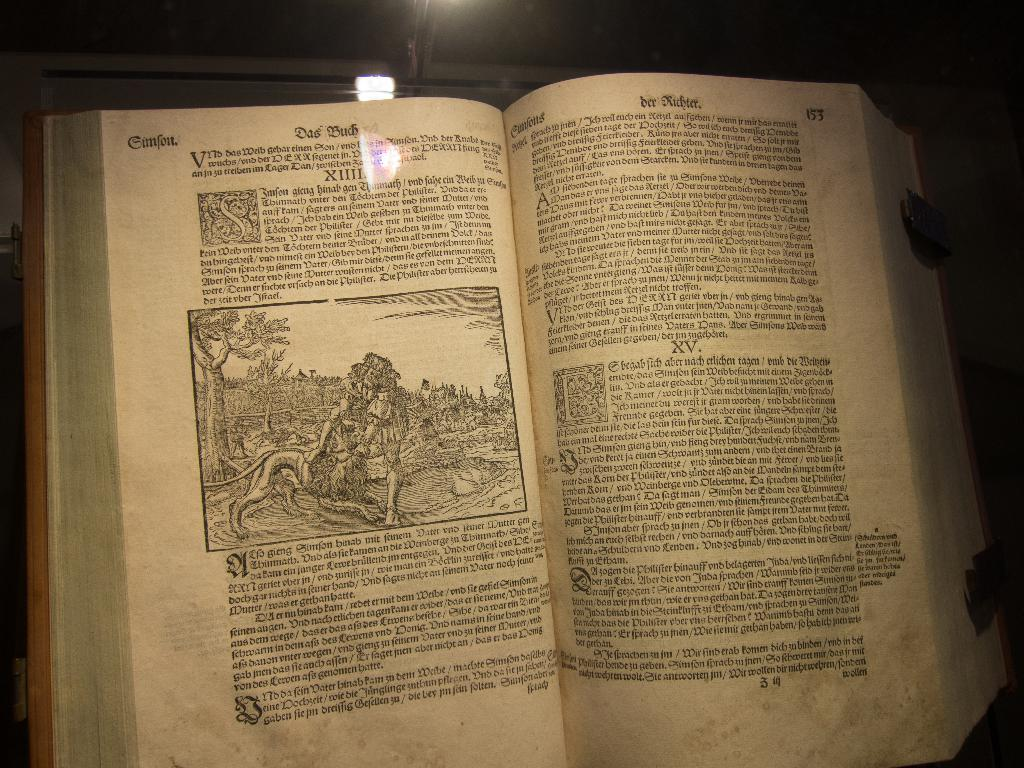What object can be seen in the image? There is a book in the image. What is inside the book? There is text in the book. How does the book reason in the image? The book does not reason in the image, as it is an inanimate object and cannot think or reason. 